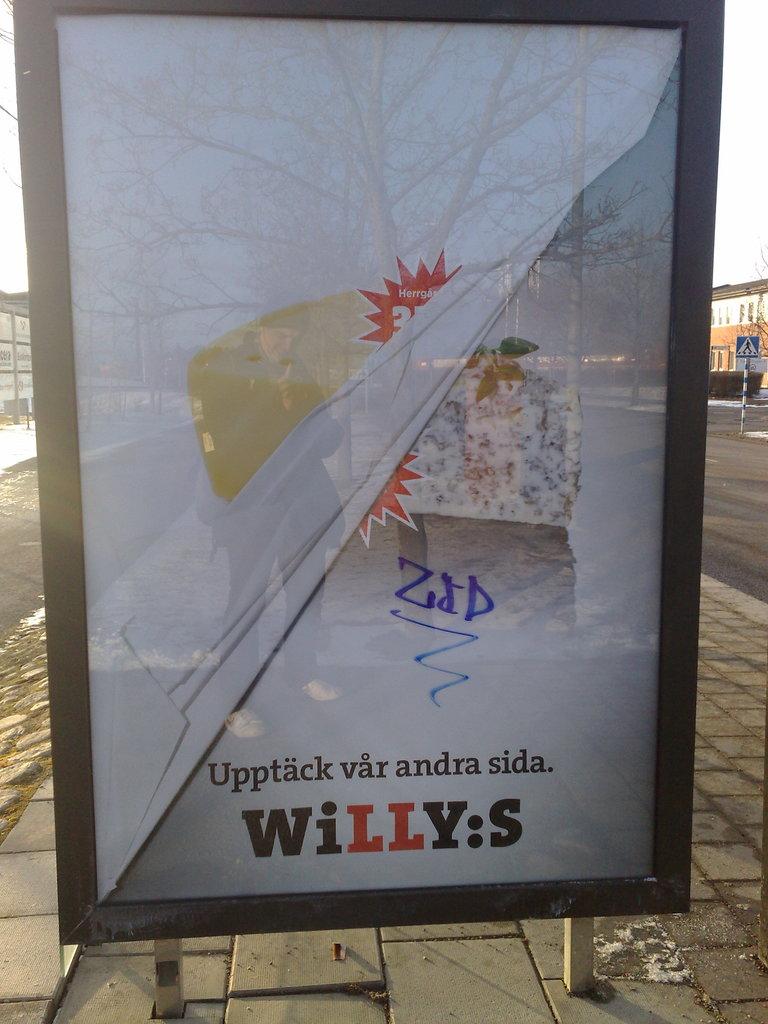In which company it is?
Ensure brevity in your answer.  Willy:s. 